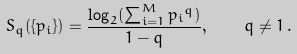<formula> <loc_0><loc_0><loc_500><loc_500>S _ { q } ( \{ p _ { i } \} ) = \frac { \log _ { 2 } ( \sum _ { i = 1 } ^ { M } { p _ { i } } ^ { q } ) } { 1 - q } , \quad q \neq 1 \, .</formula> 